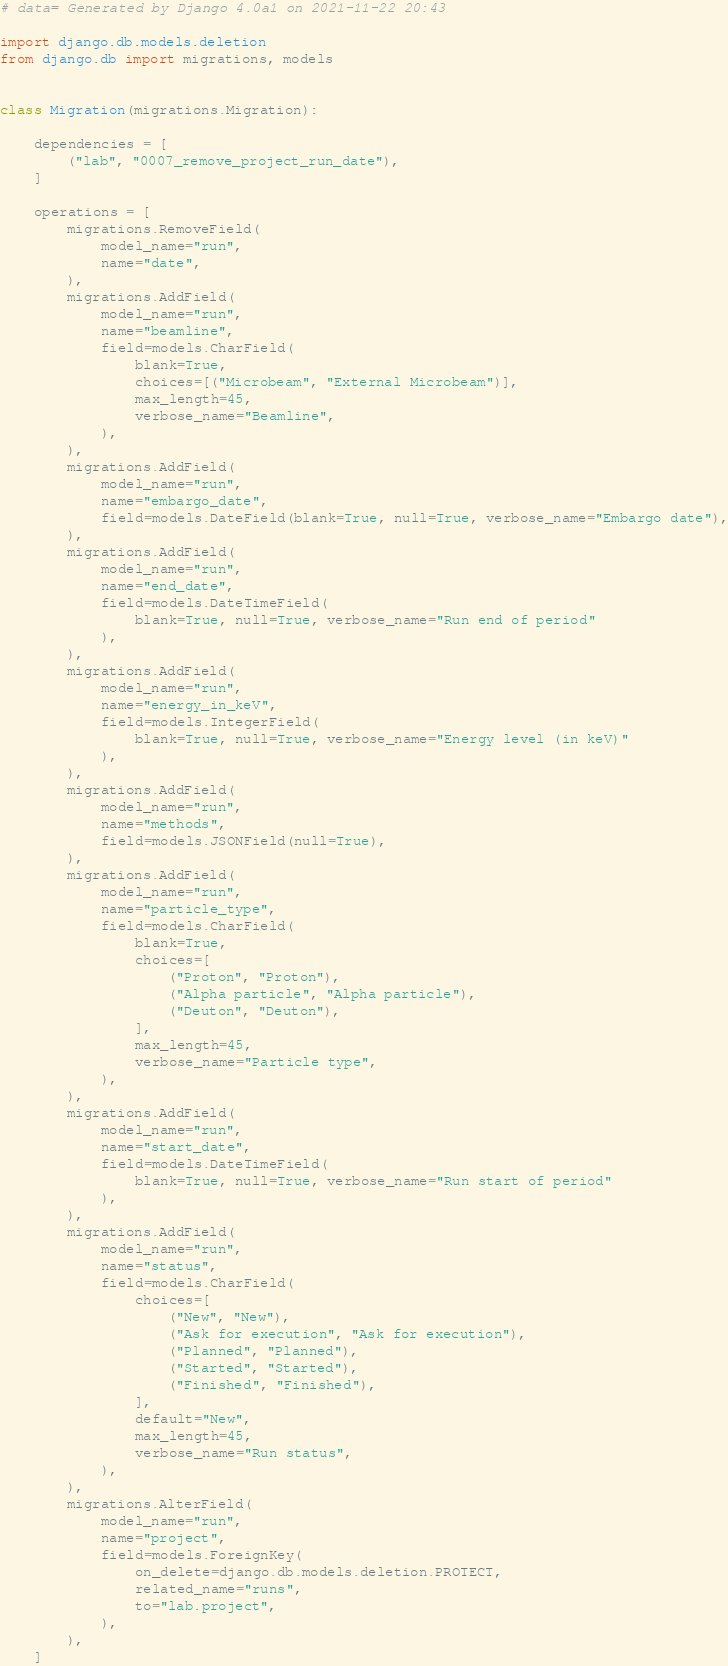Convert code to text. <code><loc_0><loc_0><loc_500><loc_500><_Python_># data= Generated by Django 4.0a1 on 2021-11-22 20:43

import django.db.models.deletion
from django.db import migrations, models


class Migration(migrations.Migration):

    dependencies = [
        ("lab", "0007_remove_project_run_date"),
    ]

    operations = [
        migrations.RemoveField(
            model_name="run",
            name="date",
        ),
        migrations.AddField(
            model_name="run",
            name="beamline",
            field=models.CharField(
                blank=True,
                choices=[("Microbeam", "External Microbeam")],
                max_length=45,
                verbose_name="Beamline",
            ),
        ),
        migrations.AddField(
            model_name="run",
            name="embargo_date",
            field=models.DateField(blank=True, null=True, verbose_name="Embargo date"),
        ),
        migrations.AddField(
            model_name="run",
            name="end_date",
            field=models.DateTimeField(
                blank=True, null=True, verbose_name="Run end of period"
            ),
        ),
        migrations.AddField(
            model_name="run",
            name="energy_in_keV",
            field=models.IntegerField(
                blank=True, null=True, verbose_name="Energy level (in keV)"
            ),
        ),
        migrations.AddField(
            model_name="run",
            name="methods",
            field=models.JSONField(null=True),
        ),
        migrations.AddField(
            model_name="run",
            name="particle_type",
            field=models.CharField(
                blank=True,
                choices=[
                    ("Proton", "Proton"),
                    ("Alpha particle", "Alpha particle"),
                    ("Deuton", "Deuton"),
                ],
                max_length=45,
                verbose_name="Particle type",
            ),
        ),
        migrations.AddField(
            model_name="run",
            name="start_date",
            field=models.DateTimeField(
                blank=True, null=True, verbose_name="Run start of period"
            ),
        ),
        migrations.AddField(
            model_name="run",
            name="status",
            field=models.CharField(
                choices=[
                    ("New", "New"),
                    ("Ask for execution", "Ask for execution"),
                    ("Planned", "Planned"),
                    ("Started", "Started"),
                    ("Finished", "Finished"),
                ],
                default="New",
                max_length=45,
                verbose_name="Run status",
            ),
        ),
        migrations.AlterField(
            model_name="run",
            name="project",
            field=models.ForeignKey(
                on_delete=django.db.models.deletion.PROTECT,
                related_name="runs",
                to="lab.project",
            ),
        ),
    ]
</code> 